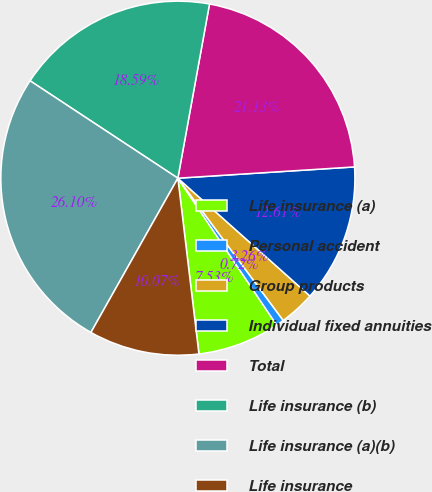Convert chart. <chart><loc_0><loc_0><loc_500><loc_500><pie_chart><fcel>Life insurance (a)<fcel>Personal accident<fcel>Group products<fcel>Individual fixed annuities<fcel>Total<fcel>Life insurance (b)<fcel>Life insurance (a)(b)<fcel>Life insurance<nl><fcel>7.53%<fcel>0.72%<fcel>3.26%<fcel>12.61%<fcel>21.13%<fcel>18.59%<fcel>26.11%<fcel>10.07%<nl></chart> 